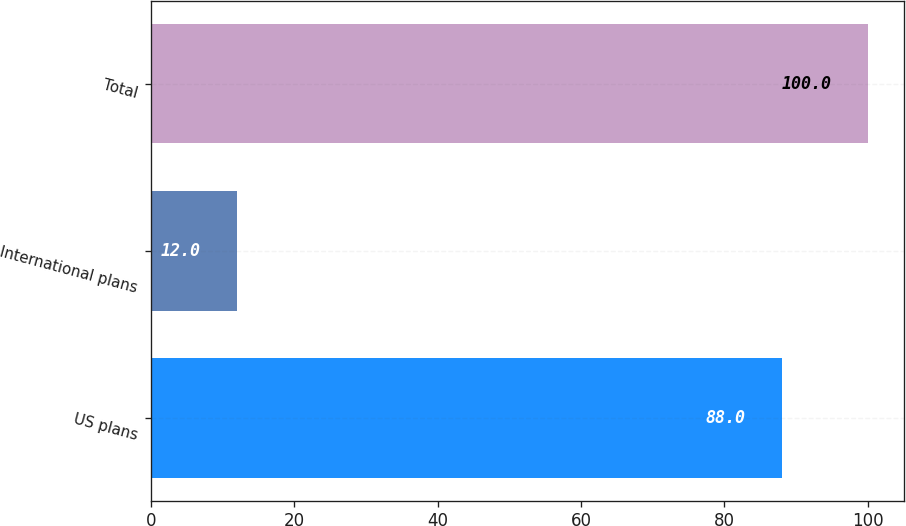Convert chart. <chart><loc_0><loc_0><loc_500><loc_500><bar_chart><fcel>US plans<fcel>International plans<fcel>Total<nl><fcel>88<fcel>12<fcel>100<nl></chart> 